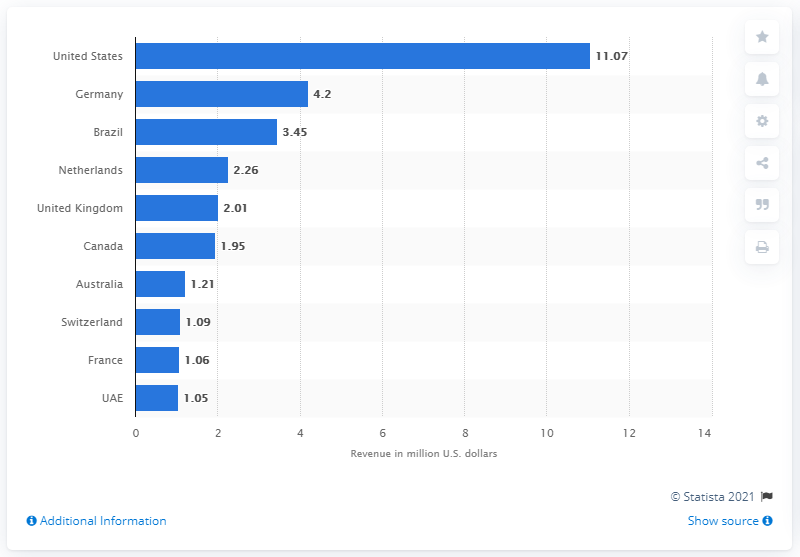Specify some key components in this picture. In the third quarter of 2020, Tinder generated approximately $11.07 million in app revenues from iOS devices. 